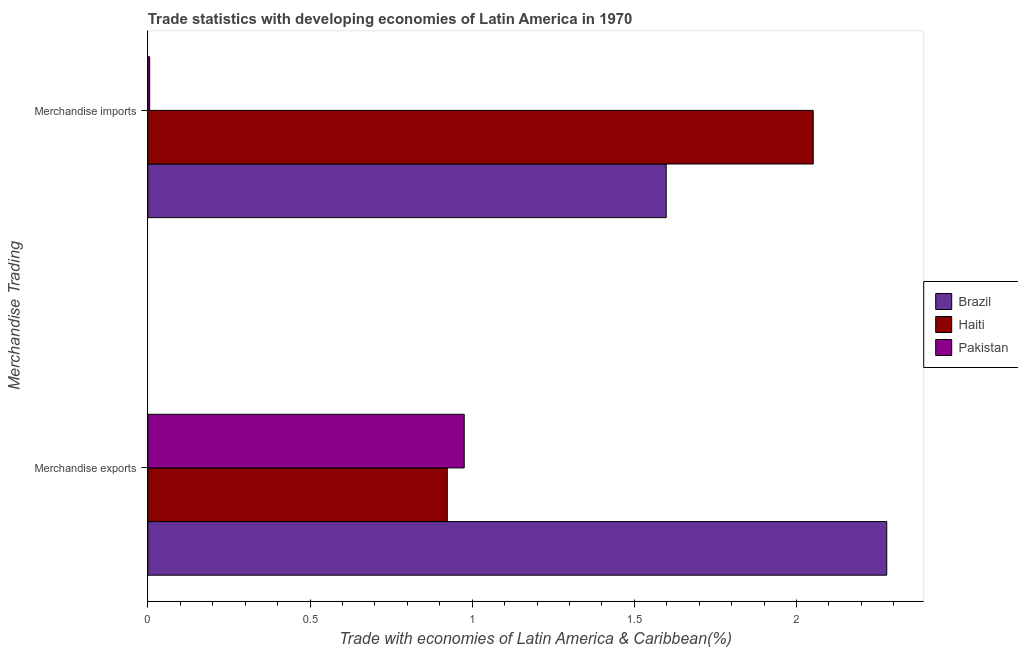How many different coloured bars are there?
Your response must be concise. 3. How many groups of bars are there?
Provide a succinct answer. 2. Are the number of bars per tick equal to the number of legend labels?
Your answer should be very brief. Yes. How many bars are there on the 1st tick from the top?
Your answer should be very brief. 3. What is the merchandise exports in Brazil?
Offer a very short reply. 2.28. Across all countries, what is the maximum merchandise imports?
Your answer should be very brief. 2.05. Across all countries, what is the minimum merchandise exports?
Give a very brief answer. 0.92. In which country was the merchandise imports minimum?
Your answer should be very brief. Pakistan. What is the total merchandise exports in the graph?
Ensure brevity in your answer.  4.18. What is the difference between the merchandise imports in Pakistan and that in Haiti?
Give a very brief answer. -2.05. What is the difference between the merchandise imports in Pakistan and the merchandise exports in Haiti?
Offer a very short reply. -0.92. What is the average merchandise exports per country?
Give a very brief answer. 1.39. What is the difference between the merchandise exports and merchandise imports in Pakistan?
Your response must be concise. 0.97. What is the ratio of the merchandise imports in Brazil to that in Pakistan?
Provide a short and direct response. 293.54. What does the 3rd bar from the top in Merchandise imports represents?
Your answer should be compact. Brazil. What does the 2nd bar from the bottom in Merchandise imports represents?
Offer a very short reply. Haiti. How many countries are there in the graph?
Your response must be concise. 3. What is the difference between two consecutive major ticks on the X-axis?
Give a very brief answer. 0.5. Does the graph contain grids?
Keep it short and to the point. No. Where does the legend appear in the graph?
Make the answer very short. Center right. What is the title of the graph?
Keep it short and to the point. Trade statistics with developing economies of Latin America in 1970. What is the label or title of the X-axis?
Offer a very short reply. Trade with economies of Latin America & Caribbean(%). What is the label or title of the Y-axis?
Your response must be concise. Merchandise Trading. What is the Trade with economies of Latin America & Caribbean(%) of Brazil in Merchandise exports?
Give a very brief answer. 2.28. What is the Trade with economies of Latin America & Caribbean(%) in Haiti in Merchandise exports?
Provide a succinct answer. 0.92. What is the Trade with economies of Latin America & Caribbean(%) of Pakistan in Merchandise exports?
Provide a succinct answer. 0.98. What is the Trade with economies of Latin America & Caribbean(%) in Brazil in Merchandise imports?
Provide a short and direct response. 1.6. What is the Trade with economies of Latin America & Caribbean(%) in Haiti in Merchandise imports?
Provide a short and direct response. 2.05. What is the Trade with economies of Latin America & Caribbean(%) of Pakistan in Merchandise imports?
Give a very brief answer. 0.01. Across all Merchandise Trading, what is the maximum Trade with economies of Latin America & Caribbean(%) of Brazil?
Ensure brevity in your answer.  2.28. Across all Merchandise Trading, what is the maximum Trade with economies of Latin America & Caribbean(%) in Haiti?
Provide a short and direct response. 2.05. Across all Merchandise Trading, what is the maximum Trade with economies of Latin America & Caribbean(%) of Pakistan?
Make the answer very short. 0.98. Across all Merchandise Trading, what is the minimum Trade with economies of Latin America & Caribbean(%) of Brazil?
Your answer should be very brief. 1.6. Across all Merchandise Trading, what is the minimum Trade with economies of Latin America & Caribbean(%) of Haiti?
Offer a very short reply. 0.92. Across all Merchandise Trading, what is the minimum Trade with economies of Latin America & Caribbean(%) of Pakistan?
Provide a short and direct response. 0.01. What is the total Trade with economies of Latin America & Caribbean(%) in Brazil in the graph?
Keep it short and to the point. 3.88. What is the total Trade with economies of Latin America & Caribbean(%) in Haiti in the graph?
Make the answer very short. 2.97. What is the difference between the Trade with economies of Latin America & Caribbean(%) of Brazil in Merchandise exports and that in Merchandise imports?
Make the answer very short. 0.68. What is the difference between the Trade with economies of Latin America & Caribbean(%) in Haiti in Merchandise exports and that in Merchandise imports?
Provide a succinct answer. -1.13. What is the difference between the Trade with economies of Latin America & Caribbean(%) in Pakistan in Merchandise exports and that in Merchandise imports?
Keep it short and to the point. 0.97. What is the difference between the Trade with economies of Latin America & Caribbean(%) of Brazil in Merchandise exports and the Trade with economies of Latin America & Caribbean(%) of Haiti in Merchandise imports?
Ensure brevity in your answer.  0.23. What is the difference between the Trade with economies of Latin America & Caribbean(%) of Brazil in Merchandise exports and the Trade with economies of Latin America & Caribbean(%) of Pakistan in Merchandise imports?
Provide a succinct answer. 2.27. What is the difference between the Trade with economies of Latin America & Caribbean(%) of Haiti in Merchandise exports and the Trade with economies of Latin America & Caribbean(%) of Pakistan in Merchandise imports?
Make the answer very short. 0.92. What is the average Trade with economies of Latin America & Caribbean(%) in Brazil per Merchandise Trading?
Provide a short and direct response. 1.94. What is the average Trade with economies of Latin America & Caribbean(%) of Haiti per Merchandise Trading?
Offer a very short reply. 1.49. What is the average Trade with economies of Latin America & Caribbean(%) in Pakistan per Merchandise Trading?
Provide a succinct answer. 0.49. What is the difference between the Trade with economies of Latin America & Caribbean(%) in Brazil and Trade with economies of Latin America & Caribbean(%) in Haiti in Merchandise exports?
Make the answer very short. 1.36. What is the difference between the Trade with economies of Latin America & Caribbean(%) in Brazil and Trade with economies of Latin America & Caribbean(%) in Pakistan in Merchandise exports?
Your response must be concise. 1.3. What is the difference between the Trade with economies of Latin America & Caribbean(%) of Haiti and Trade with economies of Latin America & Caribbean(%) of Pakistan in Merchandise exports?
Your answer should be very brief. -0.05. What is the difference between the Trade with economies of Latin America & Caribbean(%) in Brazil and Trade with economies of Latin America & Caribbean(%) in Haiti in Merchandise imports?
Offer a very short reply. -0.45. What is the difference between the Trade with economies of Latin America & Caribbean(%) of Brazil and Trade with economies of Latin America & Caribbean(%) of Pakistan in Merchandise imports?
Offer a terse response. 1.59. What is the difference between the Trade with economies of Latin America & Caribbean(%) in Haiti and Trade with economies of Latin America & Caribbean(%) in Pakistan in Merchandise imports?
Your response must be concise. 2.05. What is the ratio of the Trade with economies of Latin America & Caribbean(%) in Brazil in Merchandise exports to that in Merchandise imports?
Give a very brief answer. 1.43. What is the ratio of the Trade with economies of Latin America & Caribbean(%) of Haiti in Merchandise exports to that in Merchandise imports?
Give a very brief answer. 0.45. What is the ratio of the Trade with economies of Latin America & Caribbean(%) of Pakistan in Merchandise exports to that in Merchandise imports?
Give a very brief answer. 179.16. What is the difference between the highest and the second highest Trade with economies of Latin America & Caribbean(%) of Brazil?
Keep it short and to the point. 0.68. What is the difference between the highest and the second highest Trade with economies of Latin America & Caribbean(%) in Haiti?
Your answer should be compact. 1.13. What is the difference between the highest and the second highest Trade with economies of Latin America & Caribbean(%) of Pakistan?
Your answer should be compact. 0.97. What is the difference between the highest and the lowest Trade with economies of Latin America & Caribbean(%) in Brazil?
Your answer should be very brief. 0.68. What is the difference between the highest and the lowest Trade with economies of Latin America & Caribbean(%) in Haiti?
Keep it short and to the point. 1.13. What is the difference between the highest and the lowest Trade with economies of Latin America & Caribbean(%) in Pakistan?
Offer a very short reply. 0.97. 